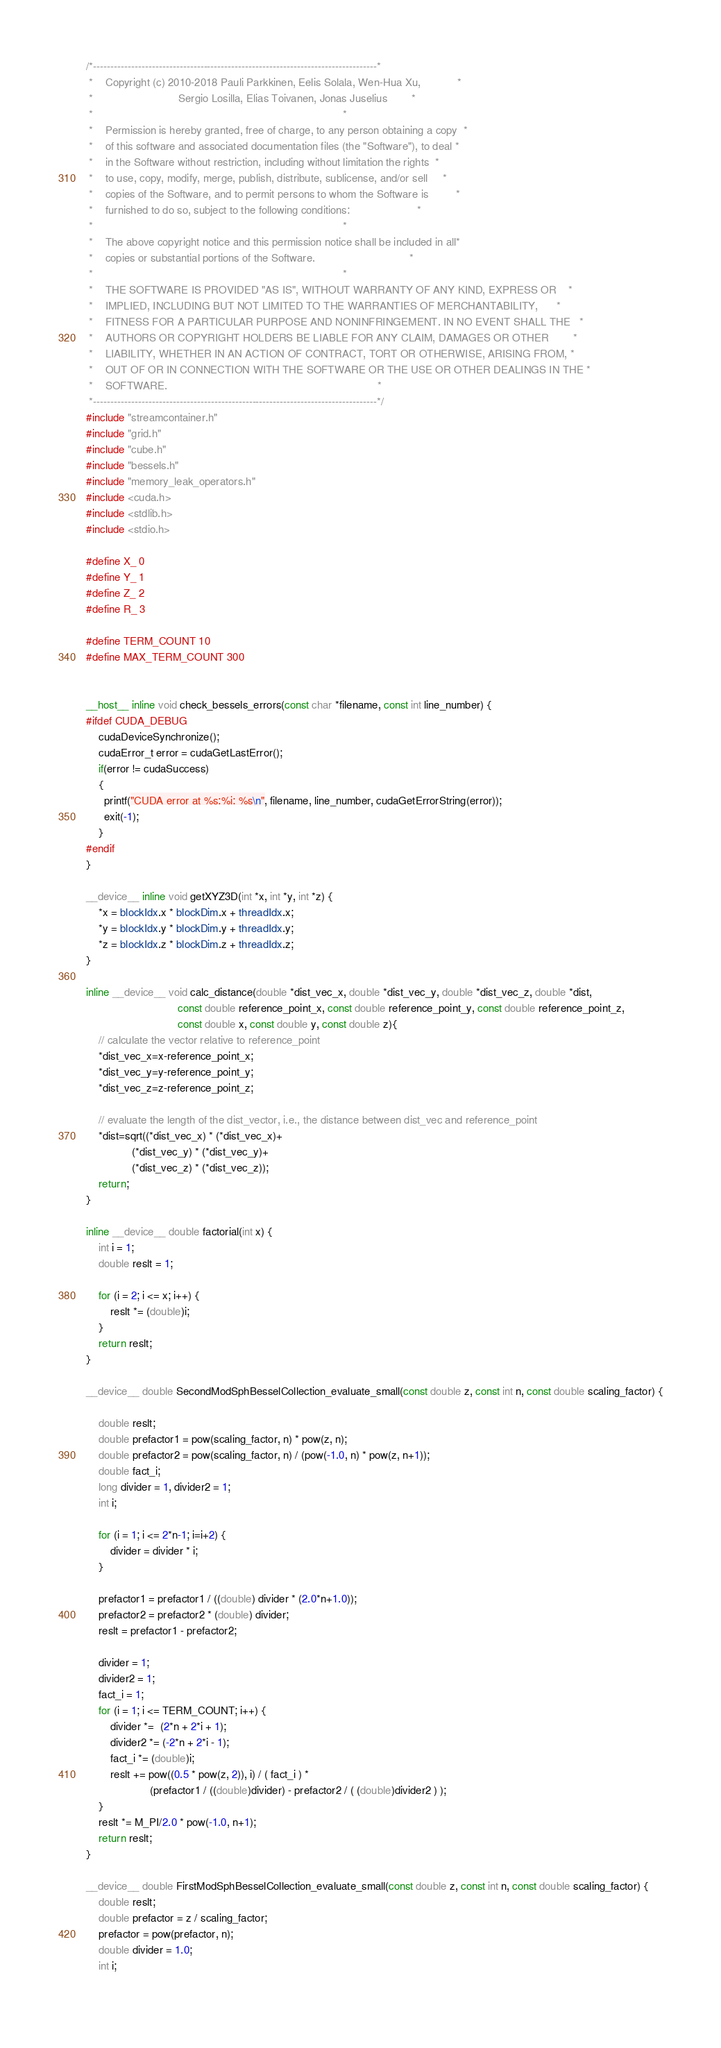Convert code to text. <code><loc_0><loc_0><loc_500><loc_500><_Cuda_>/*----------------------------------------------------------------------------------*
 *    Copyright (c) 2010-2018 Pauli Parkkinen, Eelis Solala, Wen-Hua Xu,            *
 *                            Sergio Losilla, Elias Toivanen, Jonas Juselius        *
 *                                                                                  *
 *    Permission is hereby granted, free of charge, to any person obtaining a copy  *
 *    of this software and associated documentation files (the "Software"), to deal *
 *    in the Software without restriction, including without limitation the rights  *
 *    to use, copy, modify, merge, publish, distribute, sublicense, and/or sell     *
 *    copies of the Software, and to permit persons to whom the Software is         *
 *    furnished to do so, subject to the following conditions:                      *
 *                                                                                  *
 *    The above copyright notice and this permission notice shall be included in all*
 *    copies or substantial portions of the Software.                               *
 *                                                                                  *
 *    THE SOFTWARE IS PROVIDED "AS IS", WITHOUT WARRANTY OF ANY KIND, EXPRESS OR    *
 *    IMPLIED, INCLUDING BUT NOT LIMITED TO THE WARRANTIES OF MERCHANTABILITY,      *
 *    FITNESS FOR A PARTICULAR PURPOSE AND NONINFRINGEMENT. IN NO EVENT SHALL THE   *
 *    AUTHORS OR COPYRIGHT HOLDERS BE LIABLE FOR ANY CLAIM, DAMAGES OR OTHER        *
 *    LIABILITY, WHETHER IN AN ACTION OF CONTRACT, TORT OR OTHERWISE, ARISING FROM, *
 *    OUT OF OR IN CONNECTION WITH THE SOFTWARE OR THE USE OR OTHER DEALINGS IN THE *
 *    SOFTWARE.                                                                     *
 *----------------------------------------------------------------------------------*/
#include "streamcontainer.h"
#include "grid.h"
#include "cube.h"
#include "bessels.h"
#include "memory_leak_operators.h"
#include <cuda.h>
#include <stdlib.h>
#include <stdio.h>

#define X_ 0
#define Y_ 1
#define Z_ 2
#define R_ 3

#define TERM_COUNT 10
#define MAX_TERM_COUNT 300


__host__ inline void check_bessels_errors(const char *filename, const int line_number) {
#ifdef CUDA_DEBUG
    cudaDeviceSynchronize();
    cudaError_t error = cudaGetLastError();
    if(error != cudaSuccess)
    {
      printf("CUDA error at %s:%i: %s\n", filename, line_number, cudaGetErrorString(error));
      exit(-1);
    }
#endif
}

__device__ inline void getXYZ3D(int *x, int *y, int *z) {
    *x = blockIdx.x * blockDim.x + threadIdx.x;
    *y = blockIdx.y * blockDim.y + threadIdx.y;
    *z = blockIdx.z * blockDim.z + threadIdx.z;
}

inline __device__ void calc_distance(double *dist_vec_x, double *dist_vec_y, double *dist_vec_z, double *dist,
                              const double reference_point_x, const double reference_point_y, const double reference_point_z, 
                              const double x, const double y, const double z){
    // calculate the vector relative to reference_point
    *dist_vec_x=x-reference_point_x;
    *dist_vec_y=y-reference_point_y;
    *dist_vec_z=z-reference_point_z;
    
    // evaluate the length of the dist_vector, i.e., the distance between dist_vec and reference_point
    *dist=sqrt((*dist_vec_x) * (*dist_vec_x)+
               (*dist_vec_y) * (*dist_vec_y)+
               (*dist_vec_z) * (*dist_vec_z));
    return;
}

inline __device__ double factorial(int x) {
    int i = 1;
    double reslt = 1;
    
    for (i = 2; i <= x; i++) {
        reslt *= (double)i;
    }
    return reslt;
}

__device__ double SecondModSphBesselCollection_evaluate_small(const double z, const int n, const double scaling_factor) {

    double reslt;
    double prefactor1 = pow(scaling_factor, n) * pow(z, n);
    double prefactor2 = pow(scaling_factor, n) / (pow(-1.0, n) * pow(z, n+1));
    double fact_i;
    long divider = 1, divider2 = 1;
    int i;
    
    for (i = 1; i <= 2*n-1; i=i+2) {
        divider = divider * i;
    }
    
    prefactor1 = prefactor1 / ((double) divider * (2.0*n+1.0));
    prefactor2 = prefactor2 * (double) divider;
    reslt = prefactor1 - prefactor2;
    
    divider = 1;
    divider2 = 1;
    fact_i = 1;
    for (i = 1; i <= TERM_COUNT; i++) {
        divider *=  (2*n + 2*i + 1);
        divider2 *= (-2*n + 2*i - 1);
        fact_i *= (double)i;
        reslt += pow((0.5 * pow(z, 2)), i) / ( fact_i ) *
                     (prefactor1 / ((double)divider) - prefactor2 / ( (double)divider2 ) );
    }
    reslt *= M_PI/2.0 * pow(-1.0, n+1);
    return reslt;
}

__device__ double FirstModSphBesselCollection_evaluate_small(const double z, const int n, const double scaling_factor) {
    double reslt;
    double prefactor = z / scaling_factor;
    prefactor = pow(prefactor, n);
    double divider = 1.0;
    int i;
    </code> 